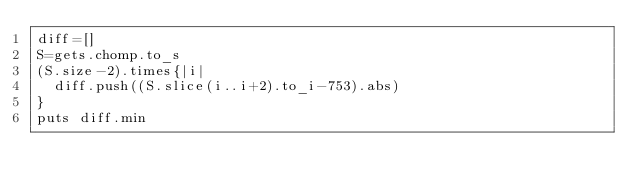Convert code to text. <code><loc_0><loc_0><loc_500><loc_500><_Ruby_>diff=[]
S=gets.chomp.to_s
(S.size-2).times{|i|
  diff.push((S.slice(i..i+2).to_i-753).abs)
}
puts diff.min
</code> 